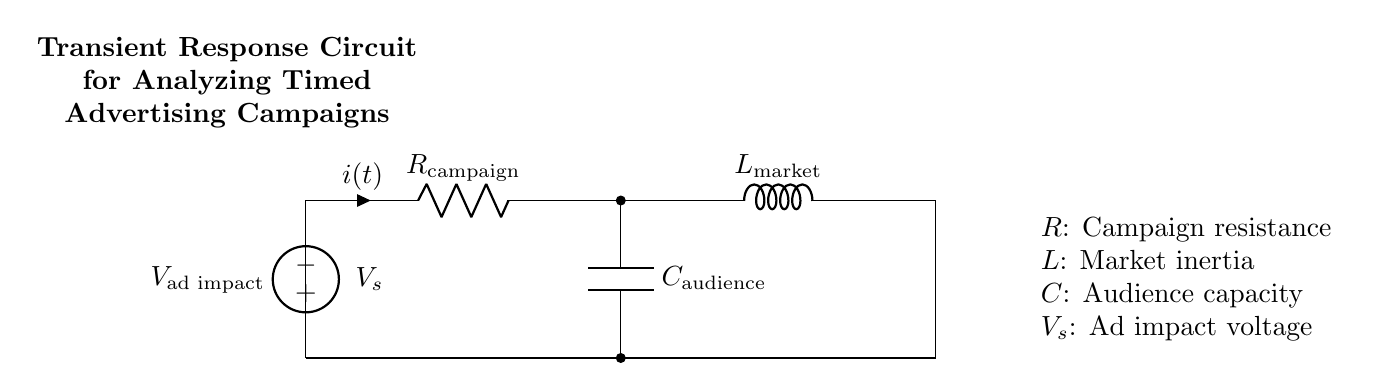What is the voltage source in the circuit? The voltage source, denoted as \( V_s \), represents the ad impact voltage influencing the campaign. It provides the potential difference necessary for the circuit to operate.
Answer: ad impact voltage What does the symbol \( R \) represent? The symbol \( R \) represents the resistance in the circuit, specifically designated as \( R_{\text{campaign}} \), which reflects the resistance encountered in the advertising campaign.
Answer: campaign resistance What component models the audience capacity? The capacitor \( C \) is labeled as \( C_{\text{audience}} \), which in this circuit represents the audience's capacity to absorb the advertising impact over time.
Answer: audience capacity What is the role of the inductor in this circuit? The inductor \( L \), labeled as \( L_{\text{market}} \), represents market inertia, influencing how quickly the market can respond to advertising efforts. Its presence is crucial for understanding transient responses.
Answer: market inertia How do resistors, inductors, and capacitors together affect transient response? The transient response in an RLC circuit occurs due to the interplay between resistance, inductance, and capacitance. Resistance dissipates energy, inductance stores energy in the magnetic field, and capacitance stores energy in the electric field, resulting in a characteristic response to changes such as the initiation of an ad campaign.
Answer: Interplay of resistance, inductance, and capacitance 